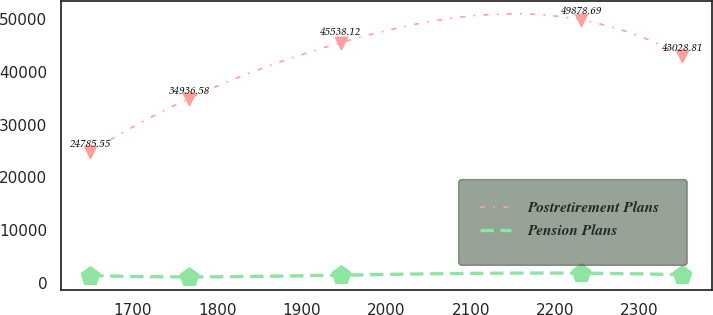<chart> <loc_0><loc_0><loc_500><loc_500><line_chart><ecel><fcel>Postretirement Plans<fcel>Pension Plans<nl><fcel>1649.23<fcel>24785.5<fcel>1344.92<nl><fcel>1766.31<fcel>34936.6<fcel>1082.54<nl><fcel>1945.89<fcel>45538.1<fcel>1415.8<nl><fcel>2230.71<fcel>49878.7<fcel>1791.36<nl><fcel>2350.67<fcel>43028.8<fcel>1486.68<nl></chart> 